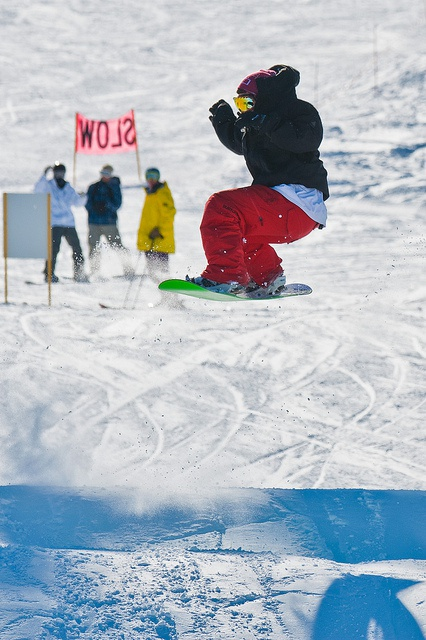Describe the objects in this image and their specific colors. I can see people in lightgray, black, brown, maroon, and darkgray tones, people in lightgray, darkgray, and darkblue tones, people in lightgray, darkblue, gray, and black tones, people in lightgray, olive, darkgray, and gray tones, and snowboard in lightgray, darkgray, and green tones in this image. 